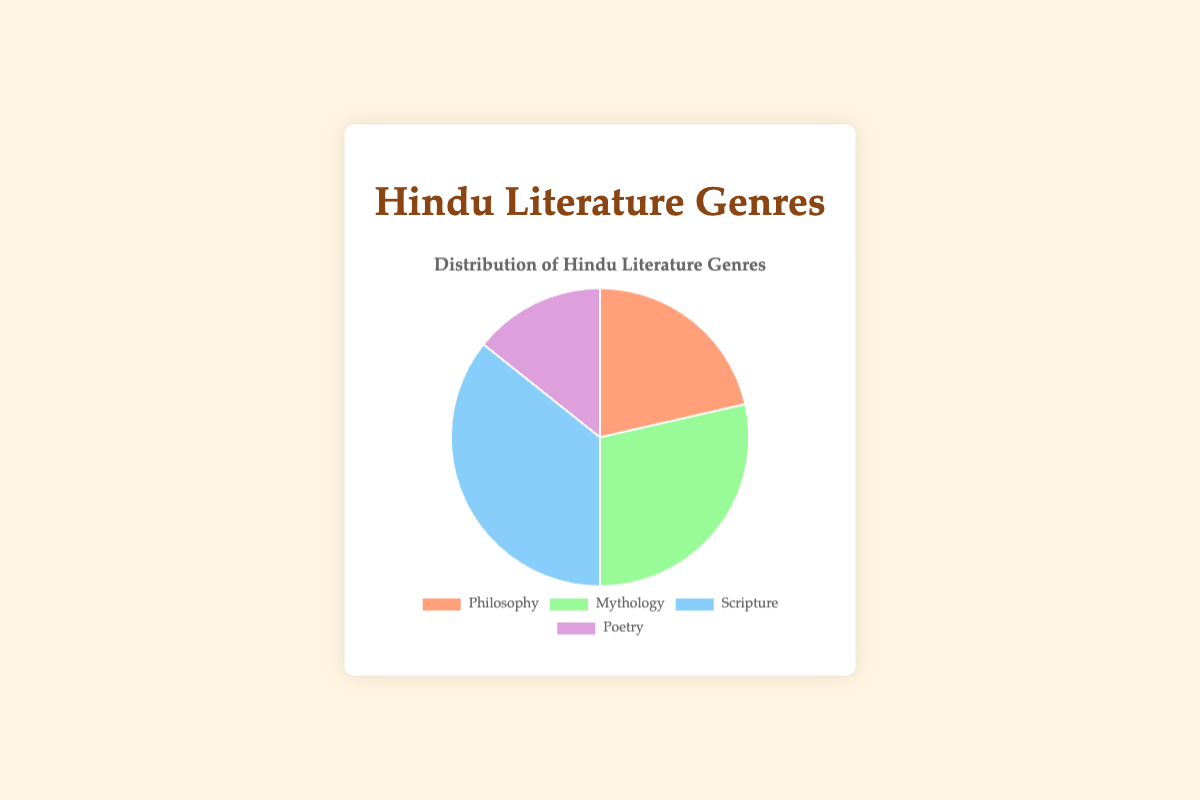Which genre has the highest number of books? By examining the pie chart, the sector with the largest area represents the genre with the highest number of books.
Answer: Scripture How many books are classified under Mythology? The pie chart should show a segment labeled "Mythology" with a corresponding slice size. Count the number of books in this genre.
Answer: 4 What is the total number of books in all genres combined? To find the total number of books, sum the counts of books in each genre: {Philosophy: 3, Mythology: 4, Scripture: 6, Poetry: 2}. So, 3 + 4 + 6 + 2 = 15.
Answer: 15 Which genre has the smallest number of books? Look for the smallest slice in the pie chart, which represents the genre with the fewest books.
Answer: Poetry How many more books are there in the genre Scripture than in Philosophy? Count the number of books in both genres and find the difference: {Scripture: 6, Philosophy: 3}. So, 6 - 3 = 3.
Answer: 3 If another book is added to the Philosophy genre, how would the distribution change visually? Adding another book to the Philosophy genre will increase its count to 4. The slice for Philosophy will become larger, decreasing the relative size of the other slices.
Answer: The Philosophy slice will get larger Compare the number of books in Philosophy and Mythology. Which genre has more books? Count the books in each genre, then compare: {Philosophy: 3, Mythology: 4}. Mythology has more books since 4 > 3.
Answer: Mythology What percentage of the books are classified as Poetry? The number of poetry books is 2. Total number of books is 15. The percentage is (2/15) * 100 ≈ 13.33%.
Answer: 13.33% What is the difference in the number of books between the genres with the most and the least books? The genre with the most books is Scripture (6), and the genre with the least is Poetry (2). The difference is 6 - 2 = 4.
Answer: 4 If two more books are added to the Poetry genre, how many books will be in Poetry, and how does it compare to the other genres? Current number of Poetry books is 2. Adding 2 books makes it 4. This will equal Philosophy (3) and be less than Mythology (4) and Scripture (6).
Answer: 4, Equal to Philosophy, less than Mythology and Scripture 